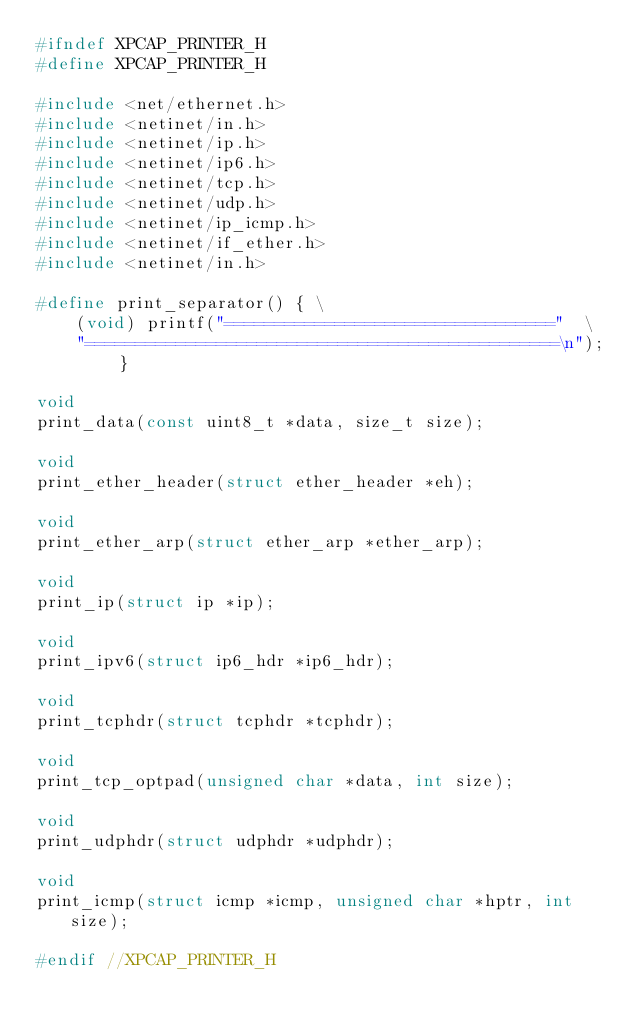<code> <loc_0><loc_0><loc_500><loc_500><_C_>#ifndef XPCAP_PRINTER_H
#define XPCAP_PRINTER_H

#include <net/ethernet.h>
#include <netinet/in.h>
#include <netinet/ip.h>
#include <netinet/ip6.h>
#include <netinet/tcp.h>
#include <netinet/udp.h>
#include <netinet/ip_icmp.h>
#include <netinet/if_ether.h>
#include <netinet/in.h>

#define print_separator() { \
	(void) printf("================================="  \
	"===============================================\n"); }

void
print_data(const uint8_t *data, size_t size);

void
print_ether_header(struct ether_header *eh);

void
print_ether_arp(struct ether_arp *ether_arp);

void
print_ip(struct ip *ip);

void
print_ipv6(struct ip6_hdr *ip6_hdr);

void
print_tcphdr(struct tcphdr *tcphdr);

void
print_tcp_optpad(unsigned char *data, int size);

void
print_udphdr(struct udphdr *udphdr);

void
print_icmp(struct icmp *icmp, unsigned char *hptr, int size);

#endif //XPCAP_PRINTER_H
</code> 